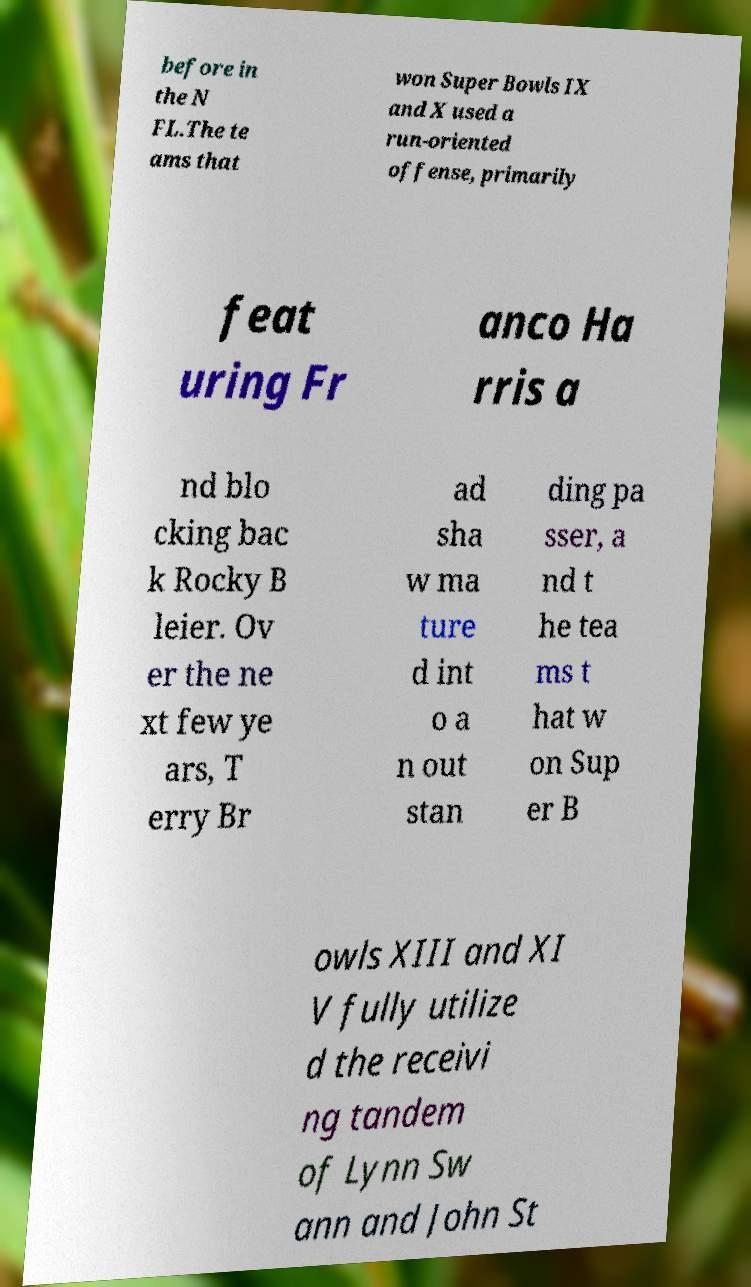I need the written content from this picture converted into text. Can you do that? before in the N FL.The te ams that won Super Bowls IX and X used a run-oriented offense, primarily feat uring Fr anco Ha rris a nd blo cking bac k Rocky B leier. Ov er the ne xt few ye ars, T erry Br ad sha w ma ture d int o a n out stan ding pa sser, a nd t he tea ms t hat w on Sup er B owls XIII and XI V fully utilize d the receivi ng tandem of Lynn Sw ann and John St 